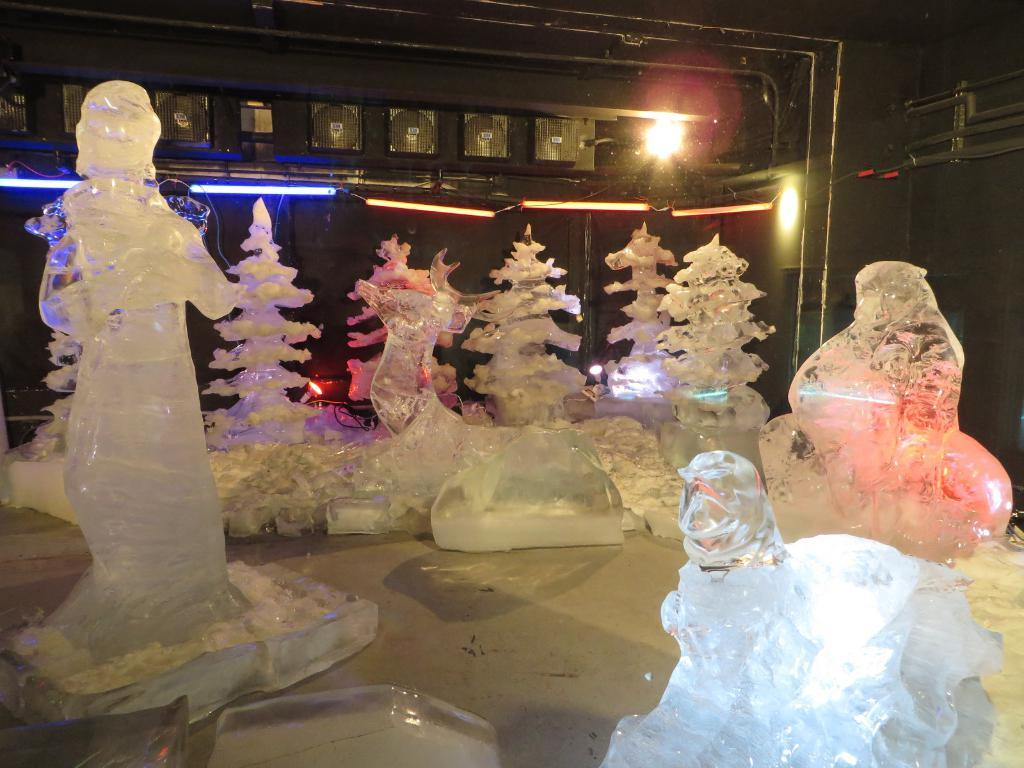What can be seen on the surface in the image? There are ice sculptures on the surface. What can be seen in the background of the image? There are lights visible in the background, and there is a wall in the background. How many parcels are being delivered by the squirrel in the image? There is no squirrel or parcel present in the image. What shape is the ice sculpture in the image? The provided facts do not mention the shape of the ice sculptures, so we cannot determine their shape from the information given. 